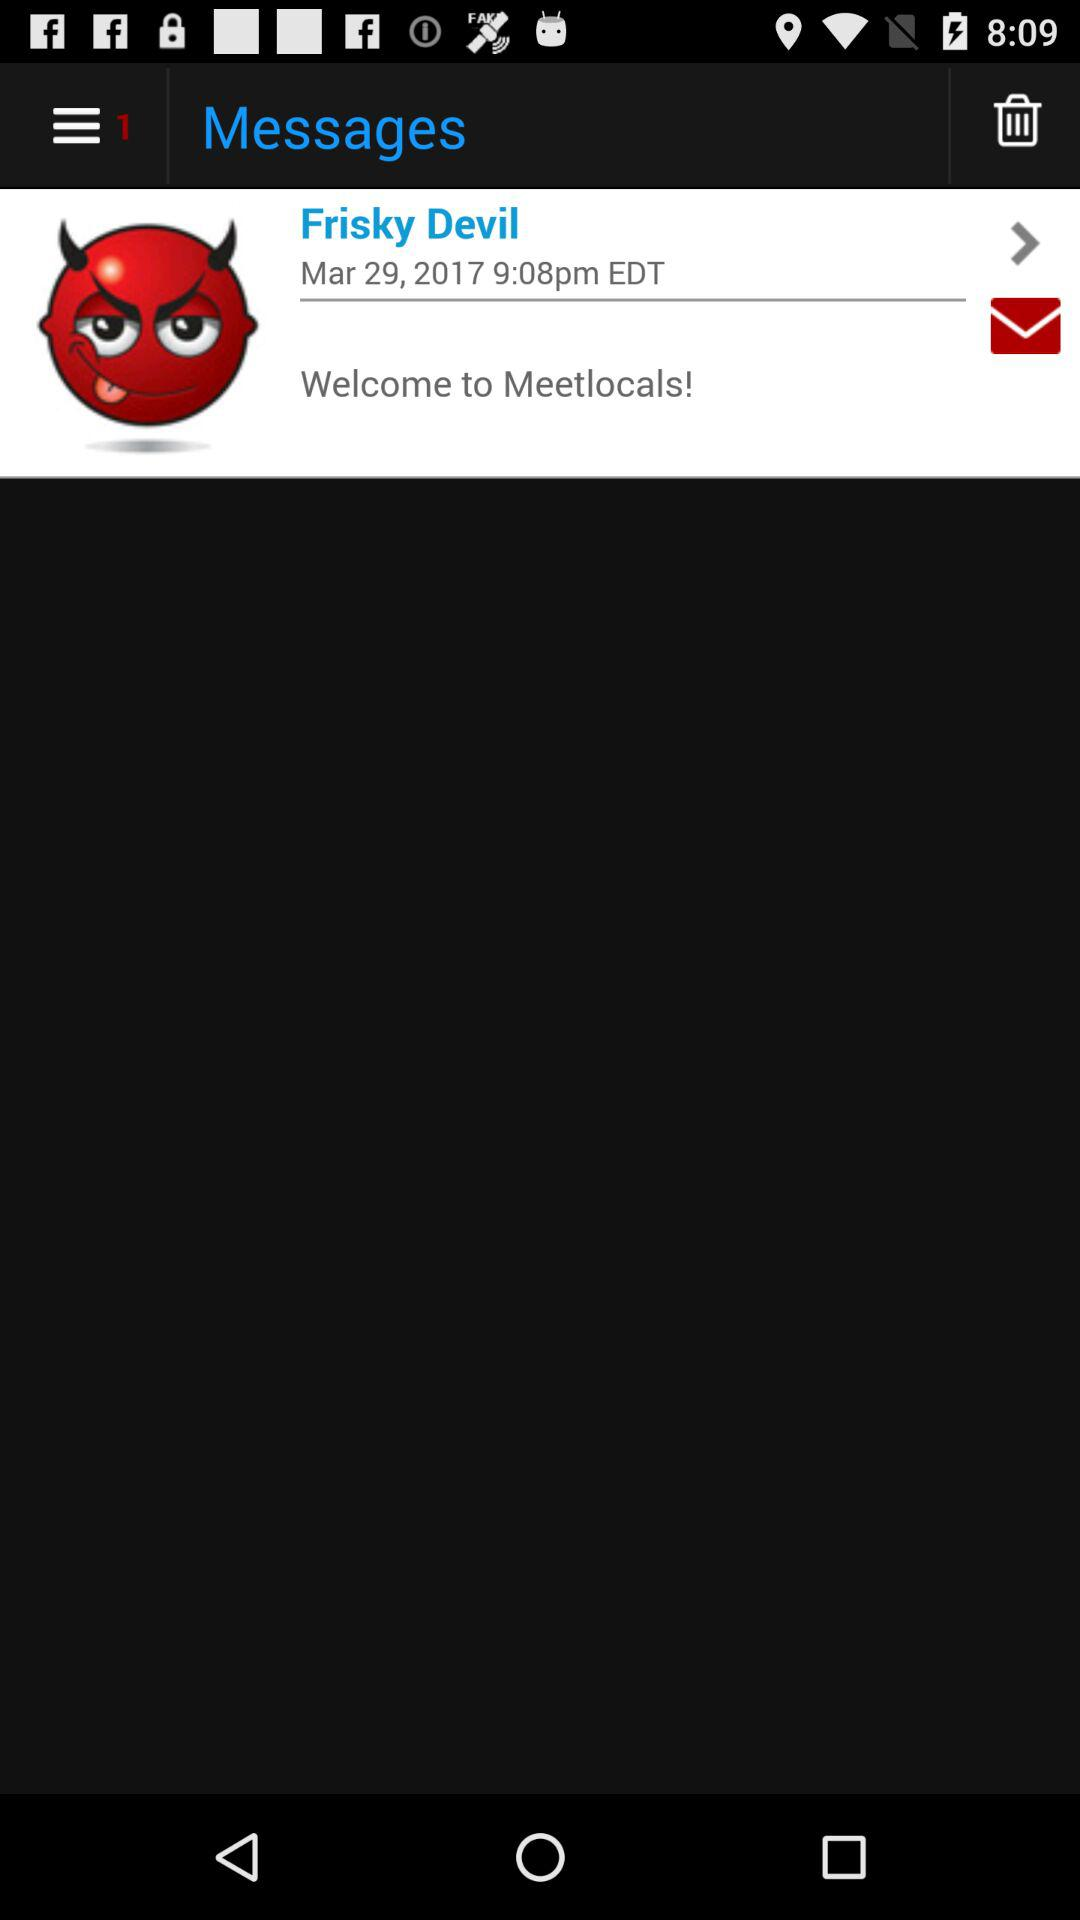What is the user name? The user name is Frisky Devil. 